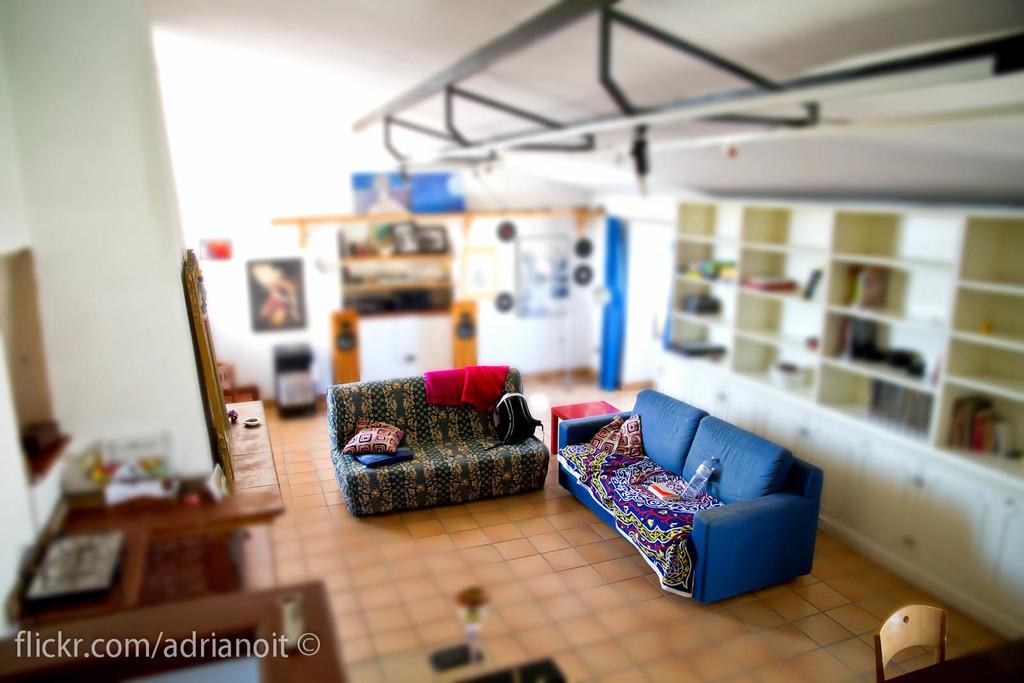<image>
Create a compact narrative representing the image presented. A large miniaturized room is captured in a flickr.com photo. 